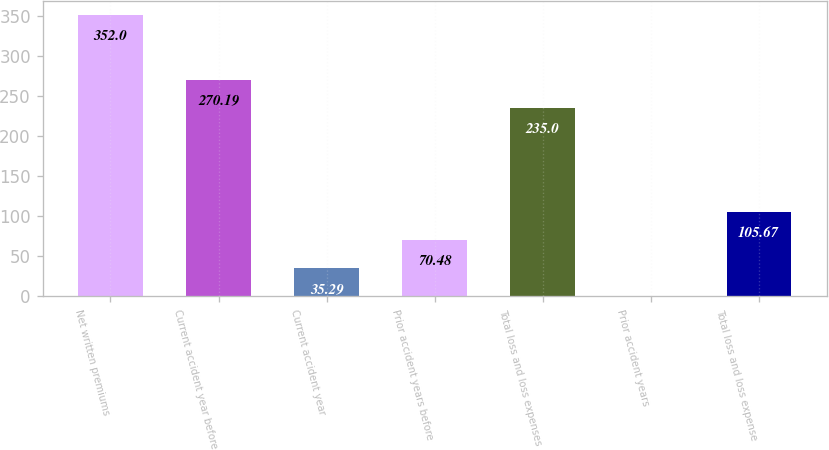Convert chart to OTSL. <chart><loc_0><loc_0><loc_500><loc_500><bar_chart><fcel>Net written premiums<fcel>Current accident year before<fcel>Current accident year<fcel>Prior accident years before<fcel>Total loss and loss expenses<fcel>Prior accident years<fcel>Total loss and loss expense<nl><fcel>352<fcel>270.19<fcel>35.29<fcel>70.48<fcel>235<fcel>0.1<fcel>105.67<nl></chart> 